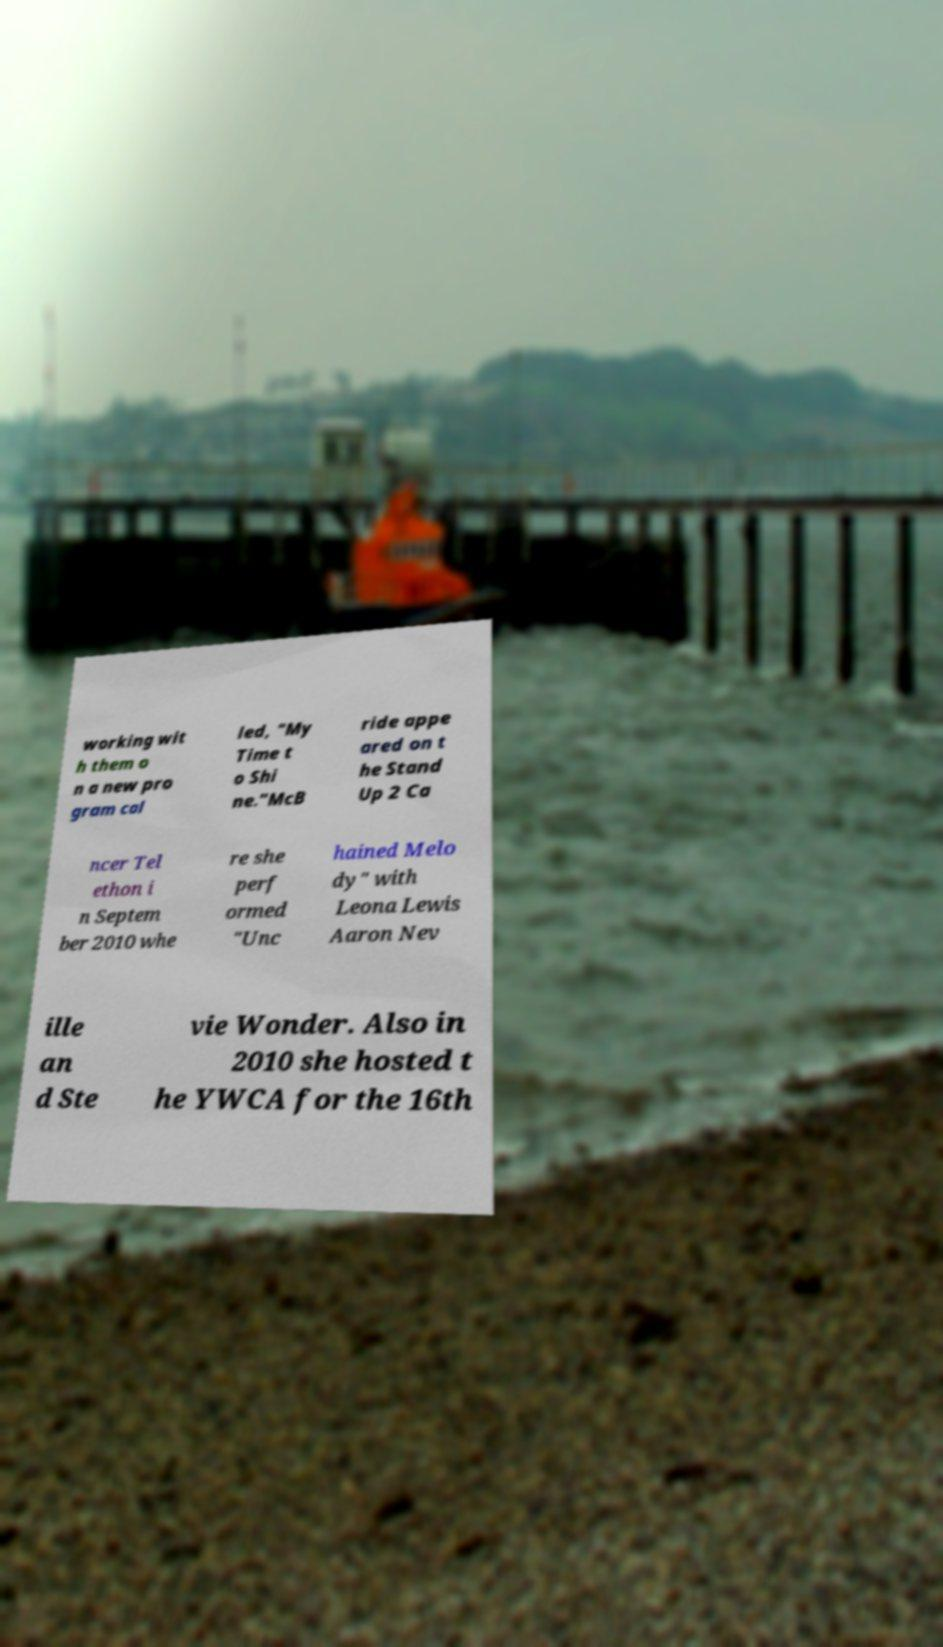What messages or text are displayed in this image? I need them in a readable, typed format. working wit h them o n a new pro gram cal led, "My Time t o Shi ne."McB ride appe ared on t he Stand Up 2 Ca ncer Tel ethon i n Septem ber 2010 whe re she perf ormed "Unc hained Melo dy" with Leona Lewis Aaron Nev ille an d Ste vie Wonder. Also in 2010 she hosted t he YWCA for the 16th 